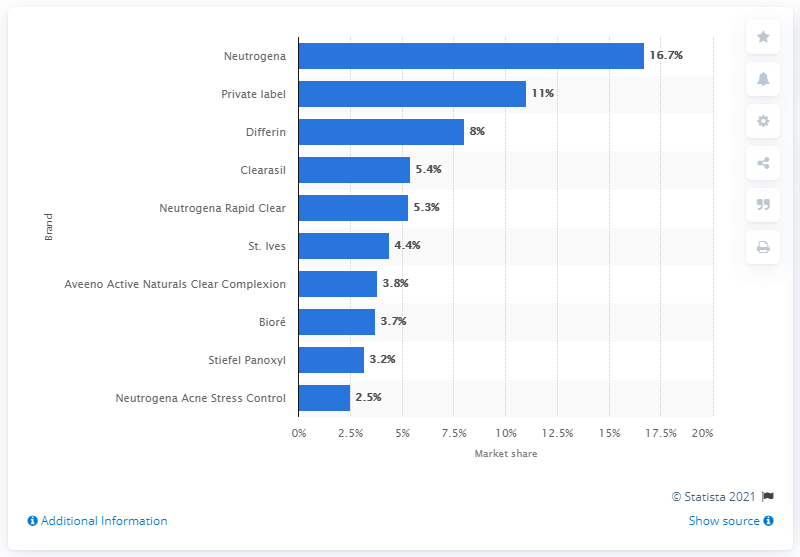Indicate a few pertinent items in this graphic. In the United States in 2019, Neutrogena was the leading acne treatment brand. In 2019, private label acne treatment brands held an estimated market share of 8%. 